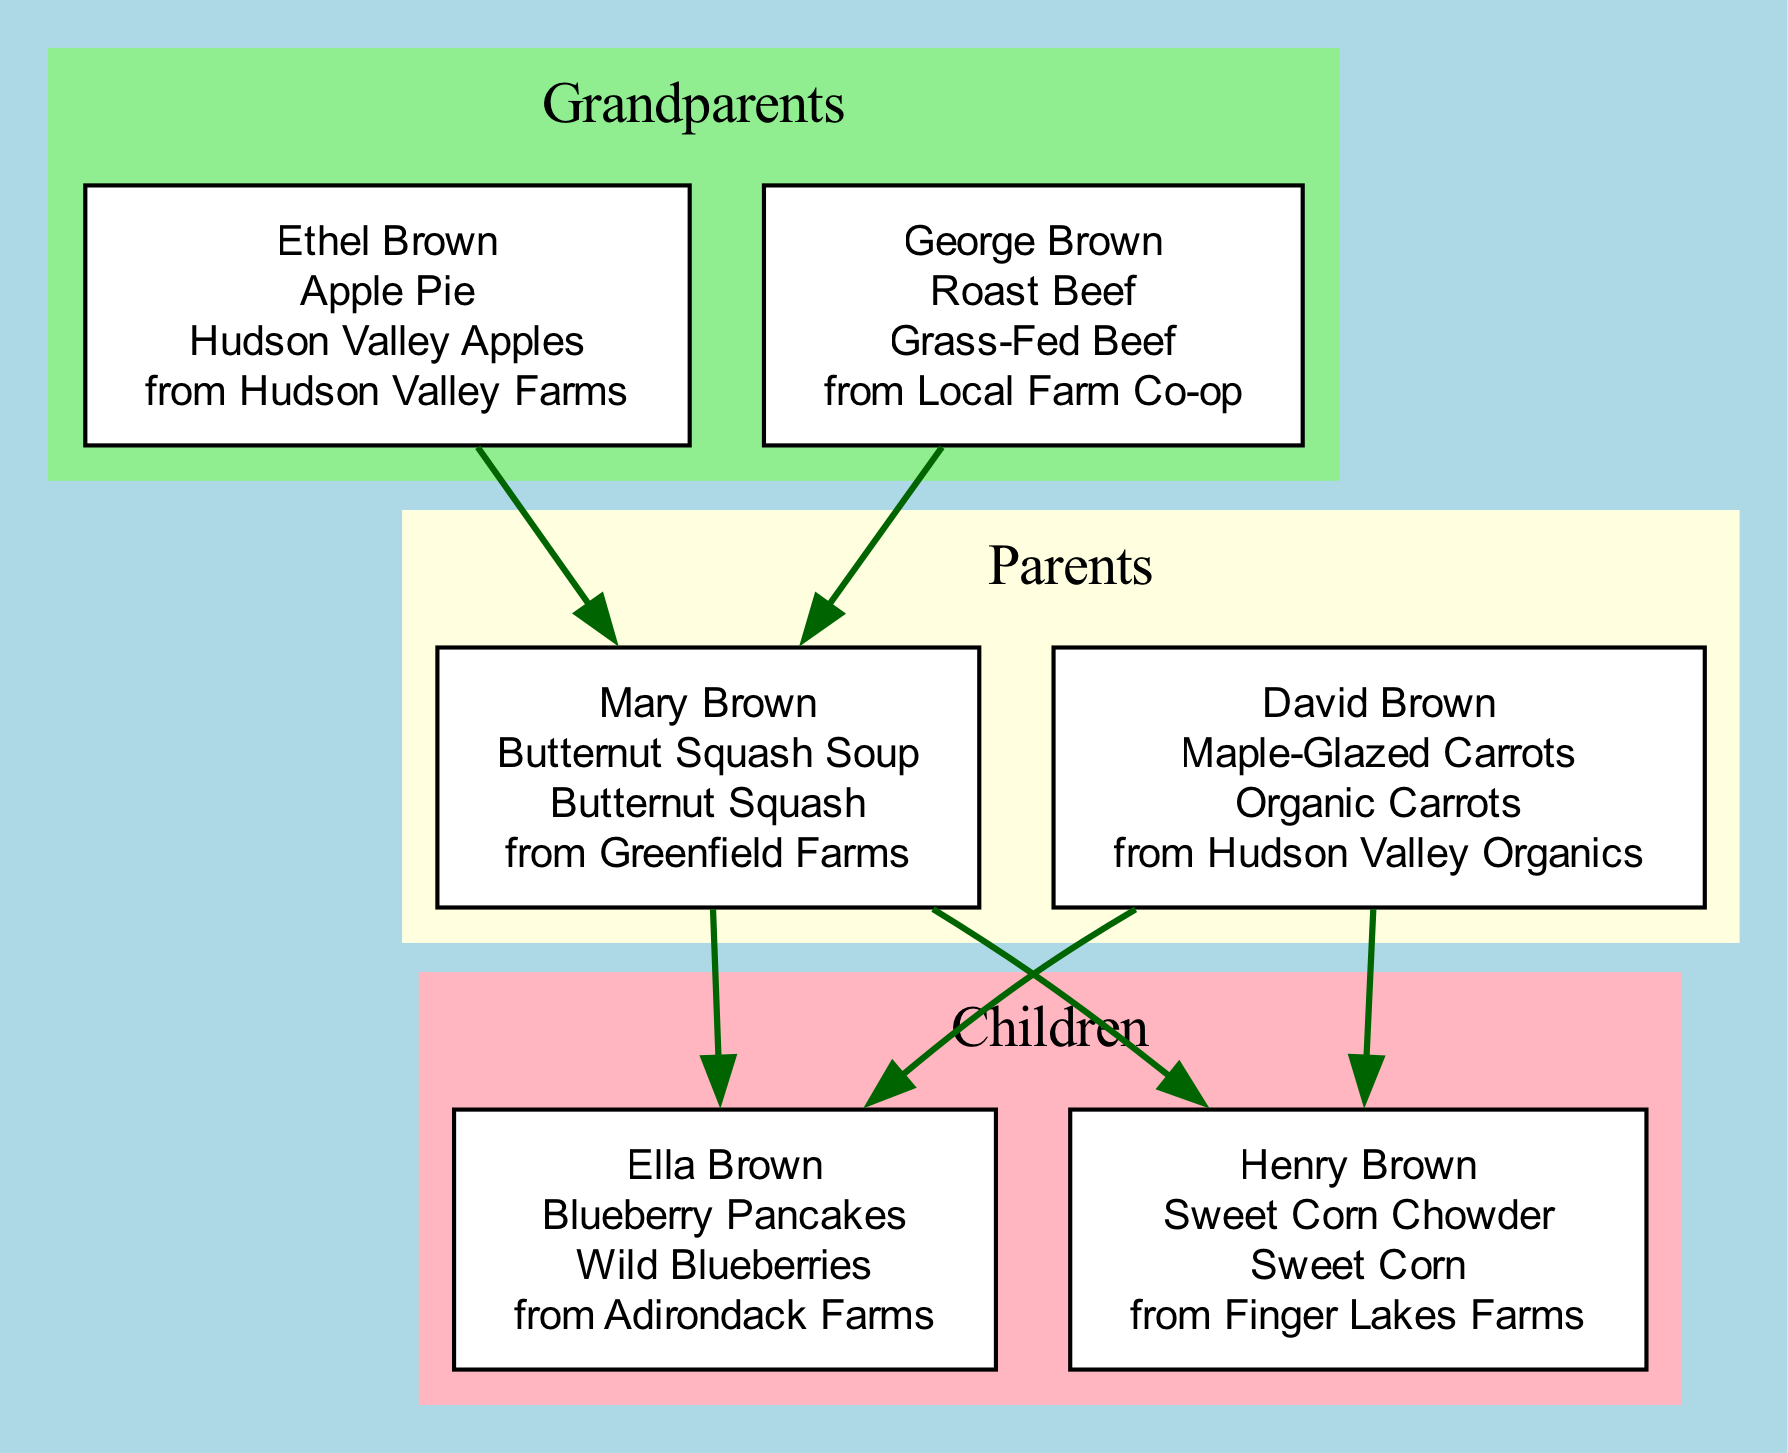What is the signature dish of George Brown? George Brown's signature dish is noted in the diagram as "Roast Beef." This can be easily found in the section detailing the grandparents.
Answer: Roast Beef How many parents are in the family tree? The diagram indicates that there are two individuals listed under the parents' section, which are Mary Brown and David Brown. This count is derived directly from the 'parents' cluster.
Answer: 2 What ingredient does Ella Brown use in her signature dish? Ella Brown's signature dish is "Blueberry Pancakes," and the ingredient listed is "Wild Blueberries." This information can be located under Ella's entry in the children’s section of the family tree.
Answer: Wild Blueberries Which family member sources their ingredient from Greenfield Farms? The ingredient sourced from Greenfield Farms belongs to Mary Brown, who uses "Butternut Squash" in her signature dish "Butternut Squash Soup." This information can be found in the parents’ section, identifying Mary.
Answer: Mary Brown Who are the grandparents of Henry Brown? Henry Brown's grandparents are Ethel Brown and George Brown, as indicated by the connections shown between the grandparents and his parents in the diagram. Since Henry is a child of Mary Brown and David Brown, tracing back the edges leads to these grandparents.
Answer: Ethel Brown and George Brown What is the significance of locally sourced ingredients in the family meals? Each family member's ingredient is linked to a local source, underscoring the family's tradition of using local farms for their dishes. The various sources provide a clear representation of how locally sourced ingredients connect the family's meals across generations.
Answer: Locally sourced ingredients How many children are there in the Brown family? The diagram shows two children mentioned, Ella Brown and Henry Brown. These names are part of the section that lists the children, making it straightforward to determine the count.
Answer: 2 Which grandparent's dish features Hudson Valley Apples? The dish associated with Hudson Valley Apples is "Apple Pie," which is linked to Ethel Brown. This is indicated in the grandparents' section of the diagram, specifically naming the ingredient and its source.
Answer: Ethel Brown What is the signature dish of David Brown? David Brown's signature dish is "Maple-Glazed Carrots," which is explicitly noted in the parents' section of the family tree.
Answer: Maple-Glazed Carrots 